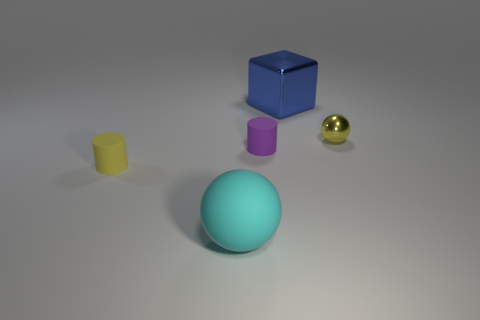How many shiny cubes have the same color as the tiny shiny sphere? Upon reviewing the image, there are no shiny cubes with the same color as the tiny shiny sphere present. The tiny shiny sphere is gold, while the cubes are of different colors. 